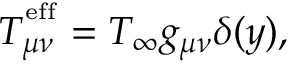<formula> <loc_0><loc_0><loc_500><loc_500>T _ { \mu \nu } ^ { ^ { e } f f } = T _ { \infty } g _ { \mu \nu } \delta ( y ) ,</formula> 